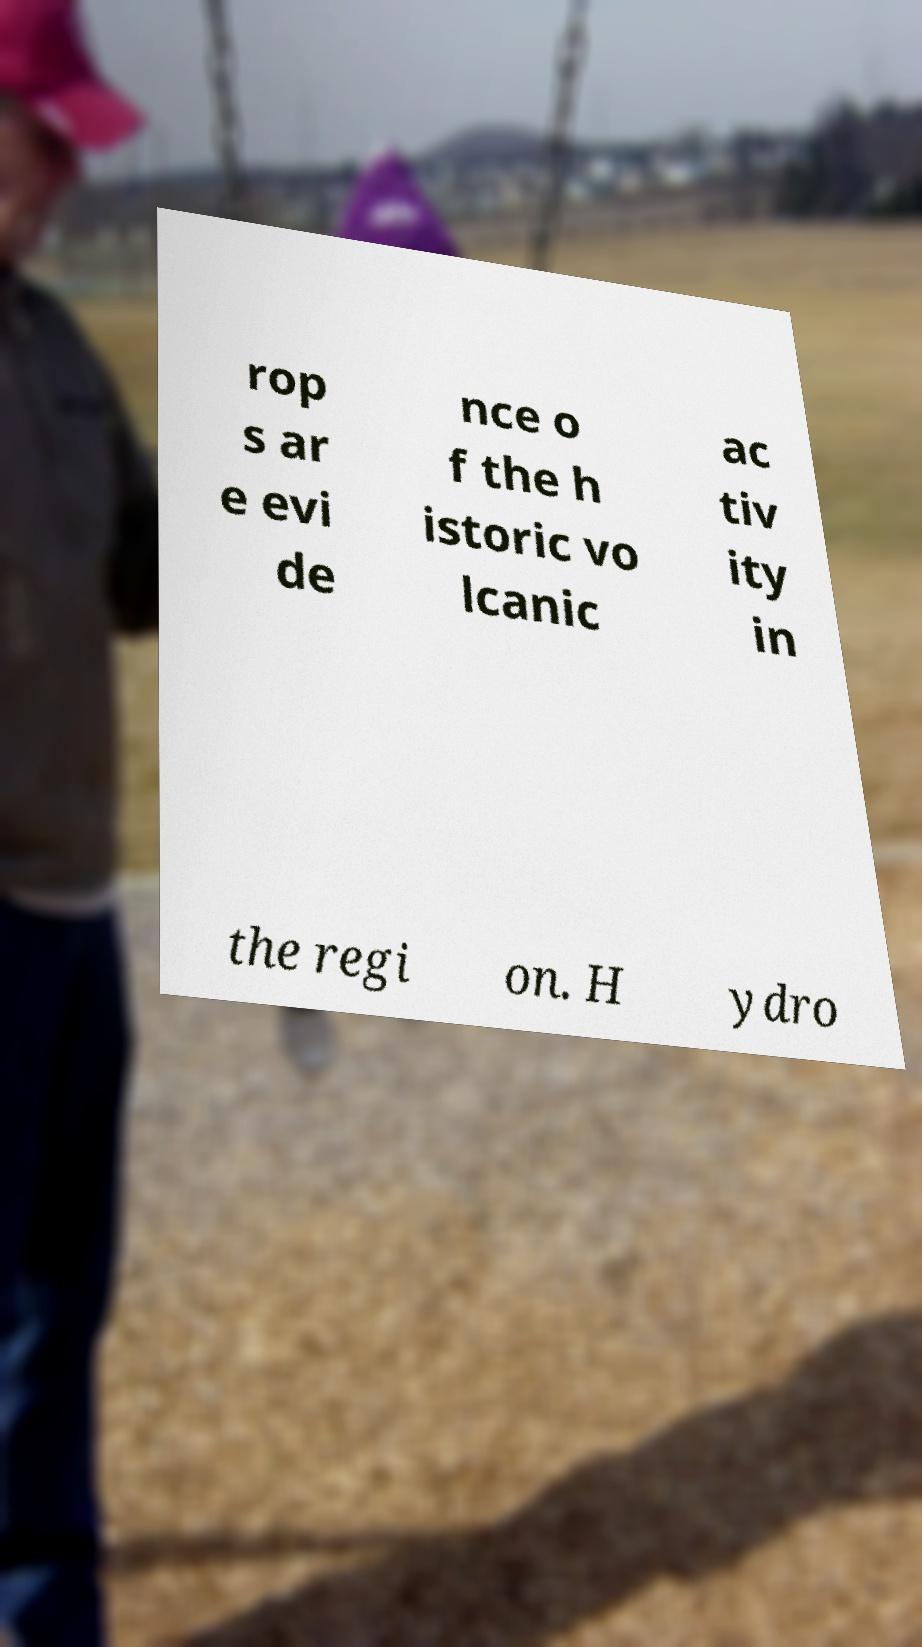For documentation purposes, I need the text within this image transcribed. Could you provide that? rop s ar e evi de nce o f the h istoric vo lcanic ac tiv ity in the regi on. H ydro 